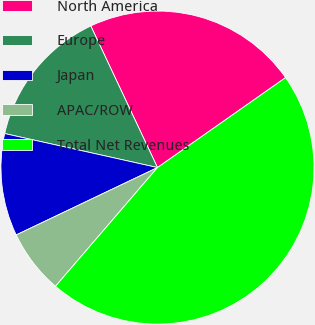<chart> <loc_0><loc_0><loc_500><loc_500><pie_chart><fcel>North America<fcel>Europe<fcel>Japan<fcel>APAC/ROW<fcel>Total Net Revenues<nl><fcel>22.26%<fcel>14.51%<fcel>10.57%<fcel>6.62%<fcel>46.04%<nl></chart> 